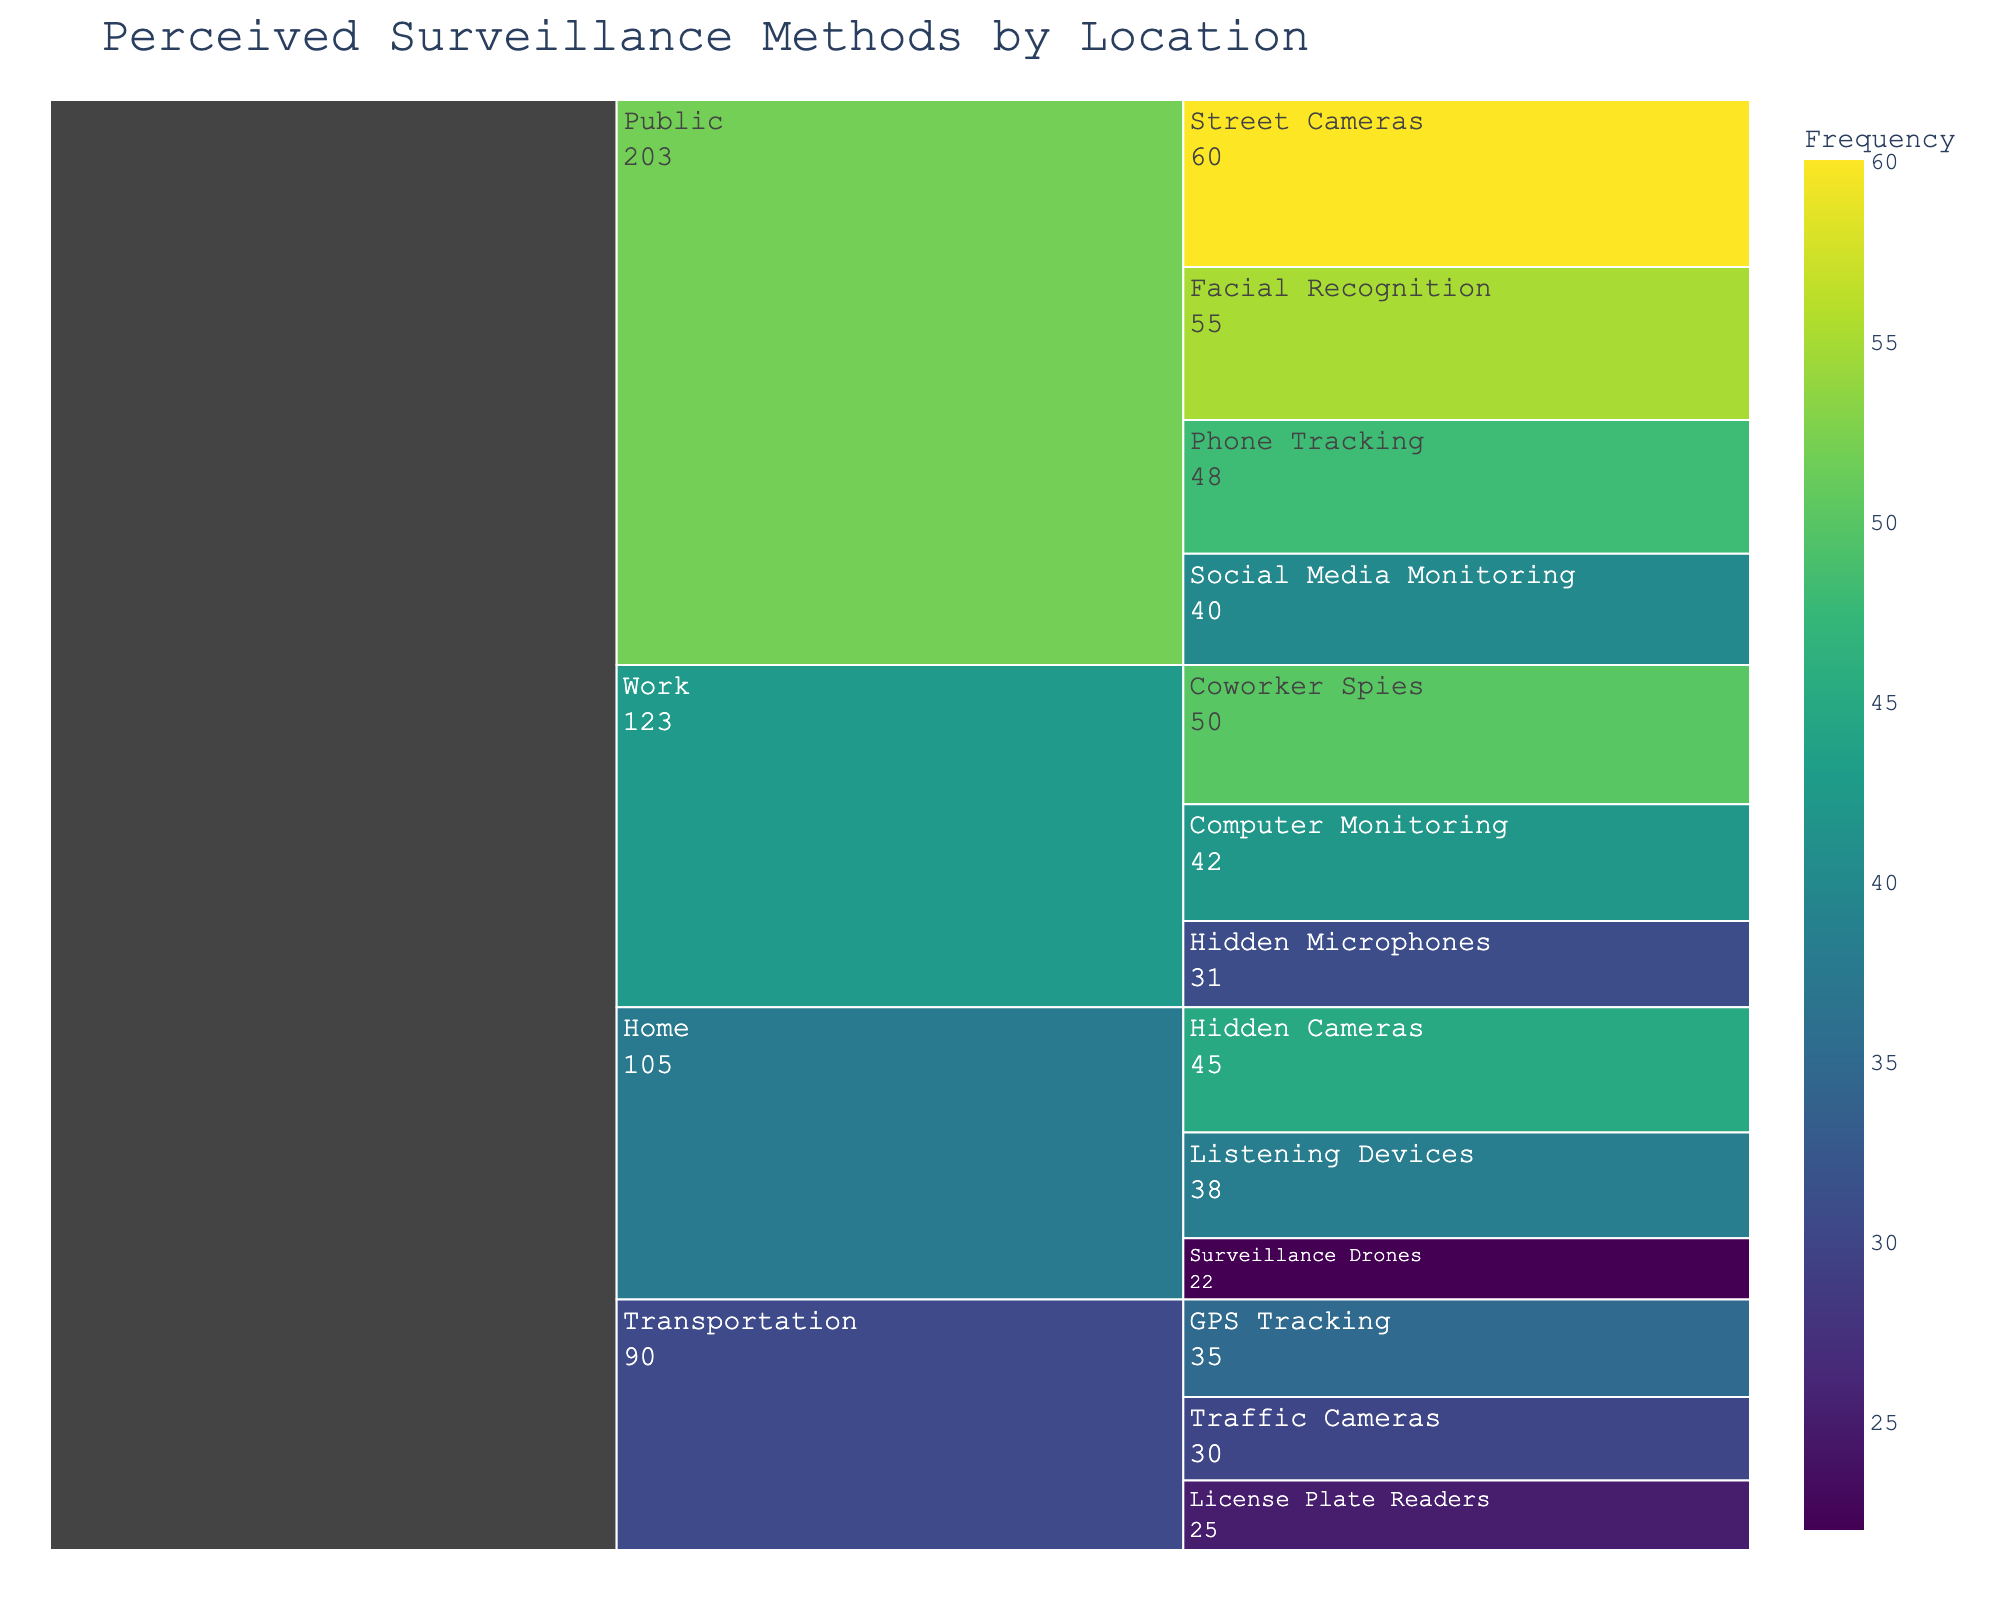What is the title of the figure? The title is displayed at the top of the figure and typically summarizes the content or subject of the chart.
Answer: Perceived Surveillance Methods by Location Which surveillance method has the highest frequency in the Home category? To answer this, look for the category "Home" and examine the branches for each method, then identify the one with the highest value.
Answer: Hidden Cameras What is the total frequency for all surveillance methods in the Work category? Sum the frequencies of all surveillance methods listed under the Work category: Coworker Spies (50), Computer Monitoring (42), and Hidden Microphones (31). Total = 50 + 42 + 31 = 123
Answer: 123 Compare the frequency of Surveillance Drones at Home with GPS Tracking in Transportation. Which one is higher? Look for the frequencies given for Surveillance Drones under Home (22) and for GPS Tracking under Transportation (35). Compare these two values.
Answer: GPS Tracking In the Public category, which surveillance method has the lowest frequency? Examine the Public category and look for the method with the smallest frequency value among Street Cameras, Facial Recognition, Phone Tracking, and Social Media Monitoring.
Answer: Social Media Monitoring What is the combined frequency of Traffic Cameras and License Plate Readers in the Transportation category? Add the frequencies of Traffic Cameras (30) and License Plate Readers (25) to get the total frequency. Total = 30 + 25 = 55
Answer: 55 How does the frequency of Listening Devices at Home compare to Computer Monitoring at Work? Compare the frequency of Listening Devices at Home (38) with Computer Monitoring at Work (42).
Answer: Computer Monitoring is higher Identify the surveillance method with the largest frequency in the Public category and provide its frequency. Look for the method with the highest value in the Public category, which is Street Cameras.
Answer: Street Cameras with a frequency of 60 What is the average frequency of all surveillance methods in the Transportation category? Sum the frequencies of all methods in the Transportation category: GPS Tracking (35), Traffic Cameras (30), and License Plate Readers (25). Then, divide this sum by the number of methods, which is 3. Average = (35 + 30 + 25)/3 = 30
Answer: 30 Which category has the highest total frequency of surveillance methods, and what is that total frequency? Calculate the total frequency for each category by summing up the frequencies of their respective methods. Compare these totals to find the highest one.
- Home: 45 + 38 + 22 = 105
- Work: 50 + 42 + 31 = 123
- Public: 60 + 55 + 48 + 40 = 203
- Transportation: 35 + 30 + 25 = 90
Public has the highest total frequency.
Answer: Public with a total frequency of 203 